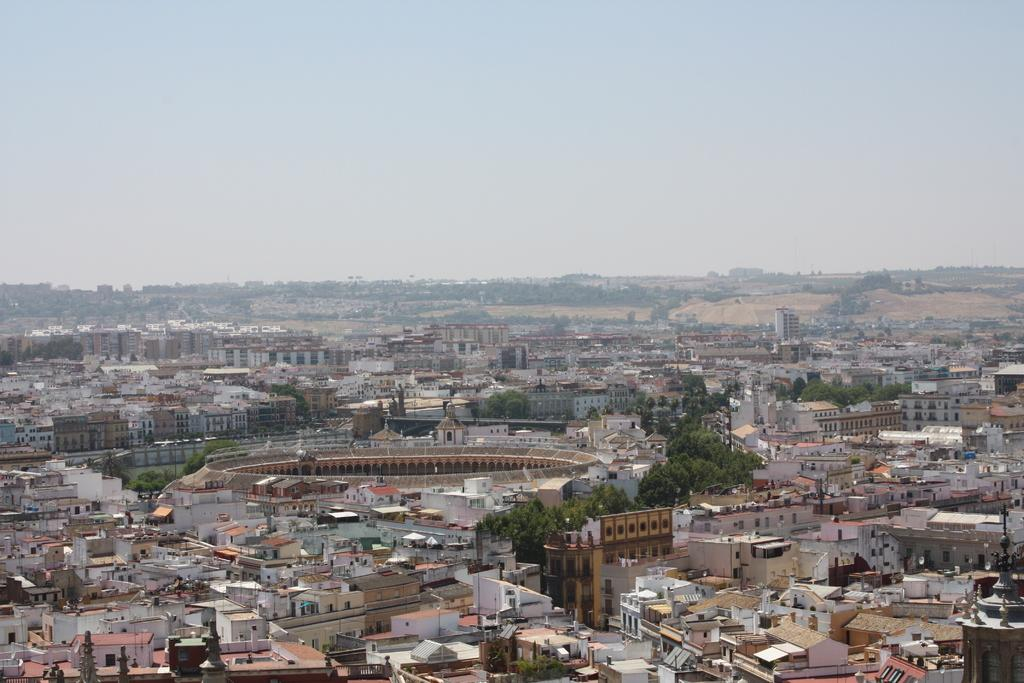What is the main structure in the center of the image? There is a building in the center of the image. What type of natural elements can be seen in the image? There are trees and mountains in the image. What is visible at the ground level in the image? The ground is visible in the image. What is visible at the top of the image? The sky is visible at the top of the image. What type of bean is growing near the building in the image? There are no beans visible in the image; it features a building, trees, mountains, ground, and sky. What letters can be seen on the trees in the image? There are no letters present on the trees in the image. 